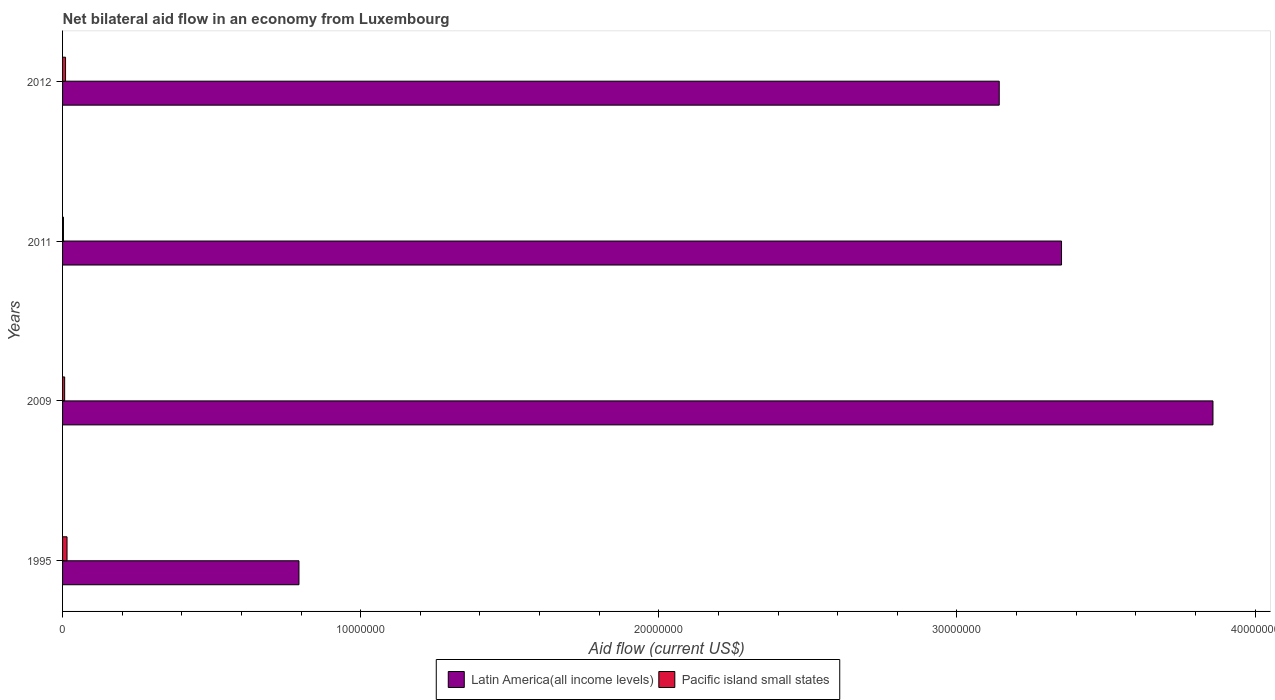Are the number of bars per tick equal to the number of legend labels?
Offer a very short reply. Yes. How many bars are there on the 4th tick from the top?
Ensure brevity in your answer.  2. How many bars are there on the 4th tick from the bottom?
Your answer should be compact. 2. In how many cases, is the number of bars for a given year not equal to the number of legend labels?
Offer a very short reply. 0. Across all years, what is the maximum net bilateral aid flow in Latin America(all income levels)?
Give a very brief answer. 3.86e+07. In which year was the net bilateral aid flow in Pacific island small states minimum?
Offer a terse response. 2011. What is the difference between the net bilateral aid flow in Latin America(all income levels) in 2009 and that in 2011?
Offer a very short reply. 5.08e+06. What is the difference between the net bilateral aid flow in Pacific island small states in 2009 and the net bilateral aid flow in Latin America(all income levels) in 2011?
Provide a short and direct response. -3.34e+07. What is the average net bilateral aid flow in Latin America(all income levels) per year?
Your response must be concise. 2.79e+07. In the year 2012, what is the difference between the net bilateral aid flow in Pacific island small states and net bilateral aid flow in Latin America(all income levels)?
Give a very brief answer. -3.13e+07. In how many years, is the net bilateral aid flow in Latin America(all income levels) greater than 8000000 US$?
Give a very brief answer. 3. What is the ratio of the net bilateral aid flow in Latin America(all income levels) in 2009 to that in 2011?
Your answer should be compact. 1.15. Is the difference between the net bilateral aid flow in Pacific island small states in 2009 and 2011 greater than the difference between the net bilateral aid flow in Latin America(all income levels) in 2009 and 2011?
Offer a terse response. No. What is the difference between the highest and the second highest net bilateral aid flow in Latin America(all income levels)?
Offer a terse response. 5.08e+06. What is the difference between the highest and the lowest net bilateral aid flow in Latin America(all income levels)?
Your response must be concise. 3.07e+07. In how many years, is the net bilateral aid flow in Pacific island small states greater than the average net bilateral aid flow in Pacific island small states taken over all years?
Give a very brief answer. 2. What does the 2nd bar from the top in 2011 represents?
Make the answer very short. Latin America(all income levels). What does the 1st bar from the bottom in 2012 represents?
Keep it short and to the point. Latin America(all income levels). How many bars are there?
Provide a succinct answer. 8. Are all the bars in the graph horizontal?
Make the answer very short. Yes. Does the graph contain any zero values?
Make the answer very short. No. Does the graph contain grids?
Offer a very short reply. No. How many legend labels are there?
Provide a succinct answer. 2. What is the title of the graph?
Keep it short and to the point. Net bilateral aid flow in an economy from Luxembourg. What is the Aid flow (current US$) in Latin America(all income levels) in 1995?
Your response must be concise. 7.93e+06. What is the Aid flow (current US$) of Latin America(all income levels) in 2009?
Offer a very short reply. 3.86e+07. What is the Aid flow (current US$) of Latin America(all income levels) in 2011?
Keep it short and to the point. 3.35e+07. What is the Aid flow (current US$) of Pacific island small states in 2011?
Your answer should be compact. 3.00e+04. What is the Aid flow (current US$) of Latin America(all income levels) in 2012?
Make the answer very short. 3.14e+07. Across all years, what is the maximum Aid flow (current US$) of Latin America(all income levels)?
Your answer should be compact. 3.86e+07. Across all years, what is the maximum Aid flow (current US$) of Pacific island small states?
Provide a short and direct response. 1.50e+05. Across all years, what is the minimum Aid flow (current US$) in Latin America(all income levels)?
Your response must be concise. 7.93e+06. What is the total Aid flow (current US$) in Latin America(all income levels) in the graph?
Provide a short and direct response. 1.11e+08. What is the difference between the Aid flow (current US$) in Latin America(all income levels) in 1995 and that in 2009?
Your answer should be very brief. -3.07e+07. What is the difference between the Aid flow (current US$) of Pacific island small states in 1995 and that in 2009?
Provide a short and direct response. 8.00e+04. What is the difference between the Aid flow (current US$) of Latin America(all income levels) in 1995 and that in 2011?
Your answer should be compact. -2.56e+07. What is the difference between the Aid flow (current US$) in Pacific island small states in 1995 and that in 2011?
Give a very brief answer. 1.20e+05. What is the difference between the Aid flow (current US$) in Latin America(all income levels) in 1995 and that in 2012?
Provide a short and direct response. -2.35e+07. What is the difference between the Aid flow (current US$) in Latin America(all income levels) in 2009 and that in 2011?
Offer a terse response. 5.08e+06. What is the difference between the Aid flow (current US$) in Pacific island small states in 2009 and that in 2011?
Offer a very short reply. 4.00e+04. What is the difference between the Aid flow (current US$) of Latin America(all income levels) in 2009 and that in 2012?
Give a very brief answer. 7.17e+06. What is the difference between the Aid flow (current US$) of Latin America(all income levels) in 2011 and that in 2012?
Keep it short and to the point. 2.09e+06. What is the difference between the Aid flow (current US$) in Latin America(all income levels) in 1995 and the Aid flow (current US$) in Pacific island small states in 2009?
Provide a short and direct response. 7.86e+06. What is the difference between the Aid flow (current US$) in Latin America(all income levels) in 1995 and the Aid flow (current US$) in Pacific island small states in 2011?
Give a very brief answer. 7.90e+06. What is the difference between the Aid flow (current US$) of Latin America(all income levels) in 1995 and the Aid flow (current US$) of Pacific island small states in 2012?
Ensure brevity in your answer.  7.83e+06. What is the difference between the Aid flow (current US$) in Latin America(all income levels) in 2009 and the Aid flow (current US$) in Pacific island small states in 2011?
Keep it short and to the point. 3.86e+07. What is the difference between the Aid flow (current US$) of Latin America(all income levels) in 2009 and the Aid flow (current US$) of Pacific island small states in 2012?
Ensure brevity in your answer.  3.85e+07. What is the difference between the Aid flow (current US$) of Latin America(all income levels) in 2011 and the Aid flow (current US$) of Pacific island small states in 2012?
Give a very brief answer. 3.34e+07. What is the average Aid flow (current US$) in Latin America(all income levels) per year?
Offer a very short reply. 2.79e+07. What is the average Aid flow (current US$) in Pacific island small states per year?
Ensure brevity in your answer.  8.75e+04. In the year 1995, what is the difference between the Aid flow (current US$) in Latin America(all income levels) and Aid flow (current US$) in Pacific island small states?
Give a very brief answer. 7.78e+06. In the year 2009, what is the difference between the Aid flow (current US$) of Latin America(all income levels) and Aid flow (current US$) of Pacific island small states?
Keep it short and to the point. 3.85e+07. In the year 2011, what is the difference between the Aid flow (current US$) of Latin America(all income levels) and Aid flow (current US$) of Pacific island small states?
Ensure brevity in your answer.  3.35e+07. In the year 2012, what is the difference between the Aid flow (current US$) in Latin America(all income levels) and Aid flow (current US$) in Pacific island small states?
Keep it short and to the point. 3.13e+07. What is the ratio of the Aid flow (current US$) in Latin America(all income levels) in 1995 to that in 2009?
Keep it short and to the point. 0.21. What is the ratio of the Aid flow (current US$) in Pacific island small states in 1995 to that in 2009?
Make the answer very short. 2.14. What is the ratio of the Aid flow (current US$) in Latin America(all income levels) in 1995 to that in 2011?
Provide a succinct answer. 0.24. What is the ratio of the Aid flow (current US$) in Pacific island small states in 1995 to that in 2011?
Provide a short and direct response. 5. What is the ratio of the Aid flow (current US$) in Latin America(all income levels) in 1995 to that in 2012?
Make the answer very short. 0.25. What is the ratio of the Aid flow (current US$) in Pacific island small states in 1995 to that in 2012?
Ensure brevity in your answer.  1.5. What is the ratio of the Aid flow (current US$) of Latin America(all income levels) in 2009 to that in 2011?
Offer a terse response. 1.15. What is the ratio of the Aid flow (current US$) in Pacific island small states in 2009 to that in 2011?
Provide a short and direct response. 2.33. What is the ratio of the Aid flow (current US$) in Latin America(all income levels) in 2009 to that in 2012?
Your response must be concise. 1.23. What is the ratio of the Aid flow (current US$) in Pacific island small states in 2009 to that in 2012?
Your answer should be very brief. 0.7. What is the ratio of the Aid flow (current US$) of Latin America(all income levels) in 2011 to that in 2012?
Make the answer very short. 1.07. What is the ratio of the Aid flow (current US$) in Pacific island small states in 2011 to that in 2012?
Make the answer very short. 0.3. What is the difference between the highest and the second highest Aid flow (current US$) of Latin America(all income levels)?
Offer a very short reply. 5.08e+06. What is the difference between the highest and the second highest Aid flow (current US$) in Pacific island small states?
Your response must be concise. 5.00e+04. What is the difference between the highest and the lowest Aid flow (current US$) in Latin America(all income levels)?
Keep it short and to the point. 3.07e+07. What is the difference between the highest and the lowest Aid flow (current US$) of Pacific island small states?
Ensure brevity in your answer.  1.20e+05. 